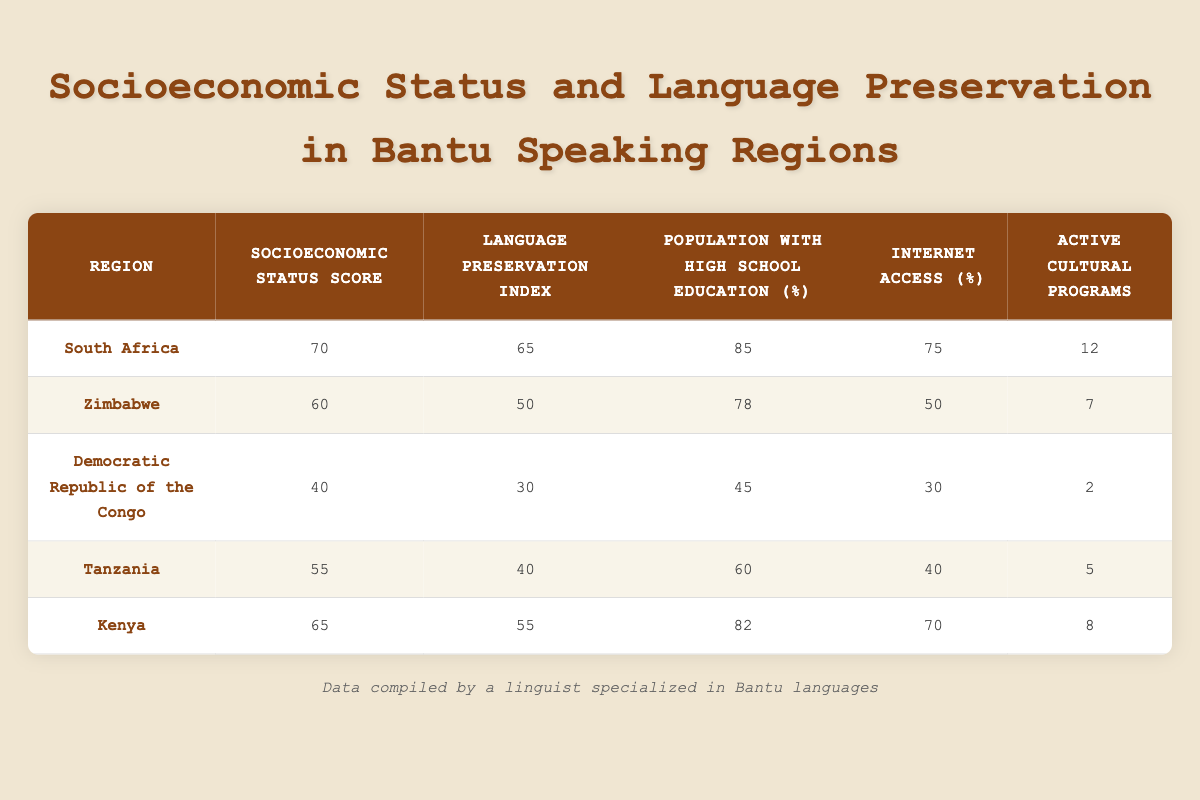What is the Language Preservation Index for South Africa? The table shows that for South Africa, the Language Preservation Index is listed as 65. You can find this value in the specific row for the South Africa region under the Language Preservation Index column.
Answer: 65 Which region has the highest Socioeconomic Status Score? By examining the table, we can see that South Africa has the highest Socioeconomic Status Score of 70 among all regions presented. It is placed in the first row and is the highest number in that column.
Answer: South Africa Is the Internet Access Percentage higher in Kenya compared to Zimbabwe? For Kenya, the Internet Access Percentage is 70%, and for Zimbabwe, it is 50%. Since 70% is greater than 50%, we conclude that Kenya indeed has a higher Internet Access Percentage than Zimbabwe.
Answer: Yes What is the average Language Preservation Index for the listed regions? To find the average, we first add up the Language Preservation Index scores: (65 + 50 + 30 + 40 + 55) = 240. Then, we divide by the number of regions, which is 5: 240/5 = 48. This gives us the average Language Preservation Index for the regions.
Answer: 48 Is there a direct correlation between the Population with High School Education and the Language Preservation Index? Analyzing the data, we compare each region's Population with High School Education and their respective Language Preservation Index. For example, South Africa with 85% and a 65 Index, Zimbabwe with 78% and a 50 Index, etc. There does seem to be a trend where higher education correlates with a higher preservation index, but since this does not specifically confirm correlation, it's more accurate to say there is potential correlation but no definitive proof.
Answer: Yes Which region has the lowest number of Active Cultural Programs and what is that number? The Democratic Republic of the Congo has the lowest number of Active Cultural Programs listed in the table, with a value of 2. This can be confirmed by looking down the Active Cultural Programs column for all regions.
Answer: 2 What is the difference in Socioeconomic Status Scores between Tanzania and Democratic Republic of the Congo? Tanzania has a Socioeconomic Status Score of 55, while the Democratic Republic of the Congo has a score of 40. To find the difference, we subtract the two scores: 55 - 40 = 15. Thus, this is the difference between the two scores.
Answer: 15 Which region has the smallest percentage of the population with high school education? Looking at the table, the Democratic Republic of the Congo has the smallest percentage at 45% for the Population with High School Education. We can identify this without any calculations by just comparing the values in the respective column.
Answer: Democratic Republic of the Congo What is the total number of Active Cultural Programs across all regions? To find the total, we add the number of Active Cultural Programs from all regions: 12 + 7 + 2 + 5 + 8 = 34. Therefore, the total number of Active Cultural Programs is derived from this summation.
Answer: 34 